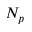Convert formula to latex. <formula><loc_0><loc_0><loc_500><loc_500>N _ { p }</formula> 